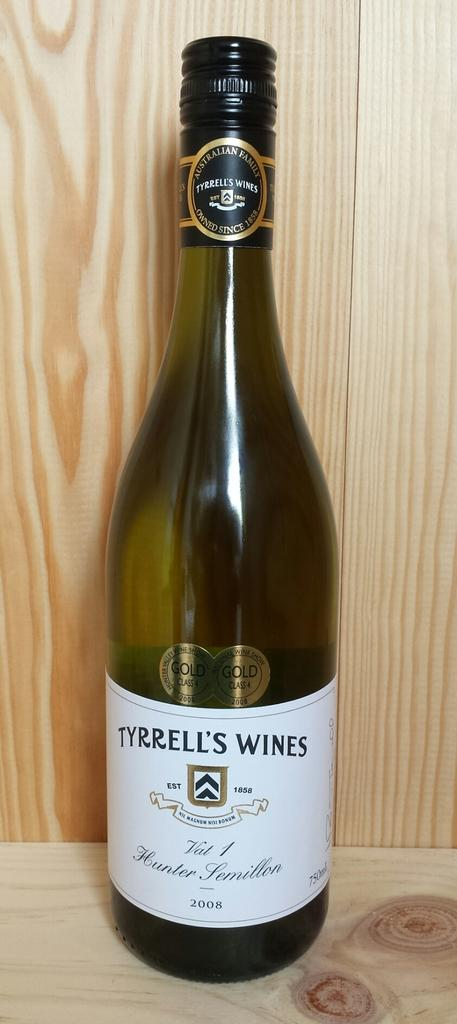<image>
Render a clear and concise summary of the photo. A bottle of white wine with the name Tyrell's on it 